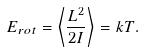Convert formula to latex. <formula><loc_0><loc_0><loc_500><loc_500>E _ { r o t } = \left < \frac { L ^ { 2 } } { 2 I } \right > = k T .</formula> 